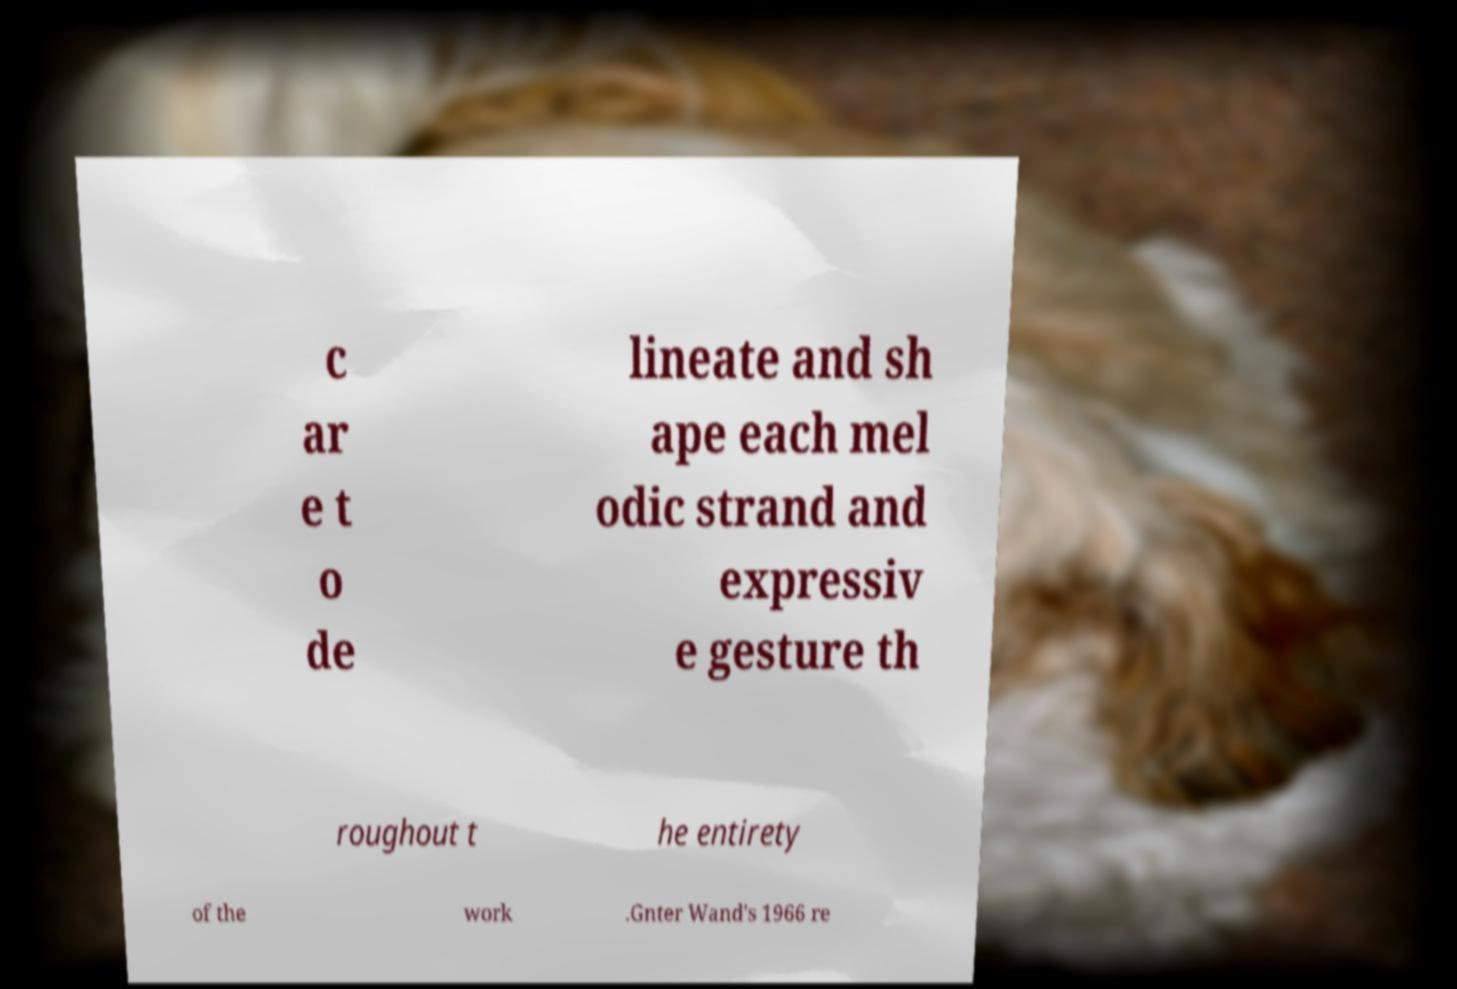Can you read and provide the text displayed in the image?This photo seems to have some interesting text. Can you extract and type it out for me? c ar e t o de lineate and sh ape each mel odic strand and expressiv e gesture th roughout t he entirety of the work .Gnter Wand's 1966 re 